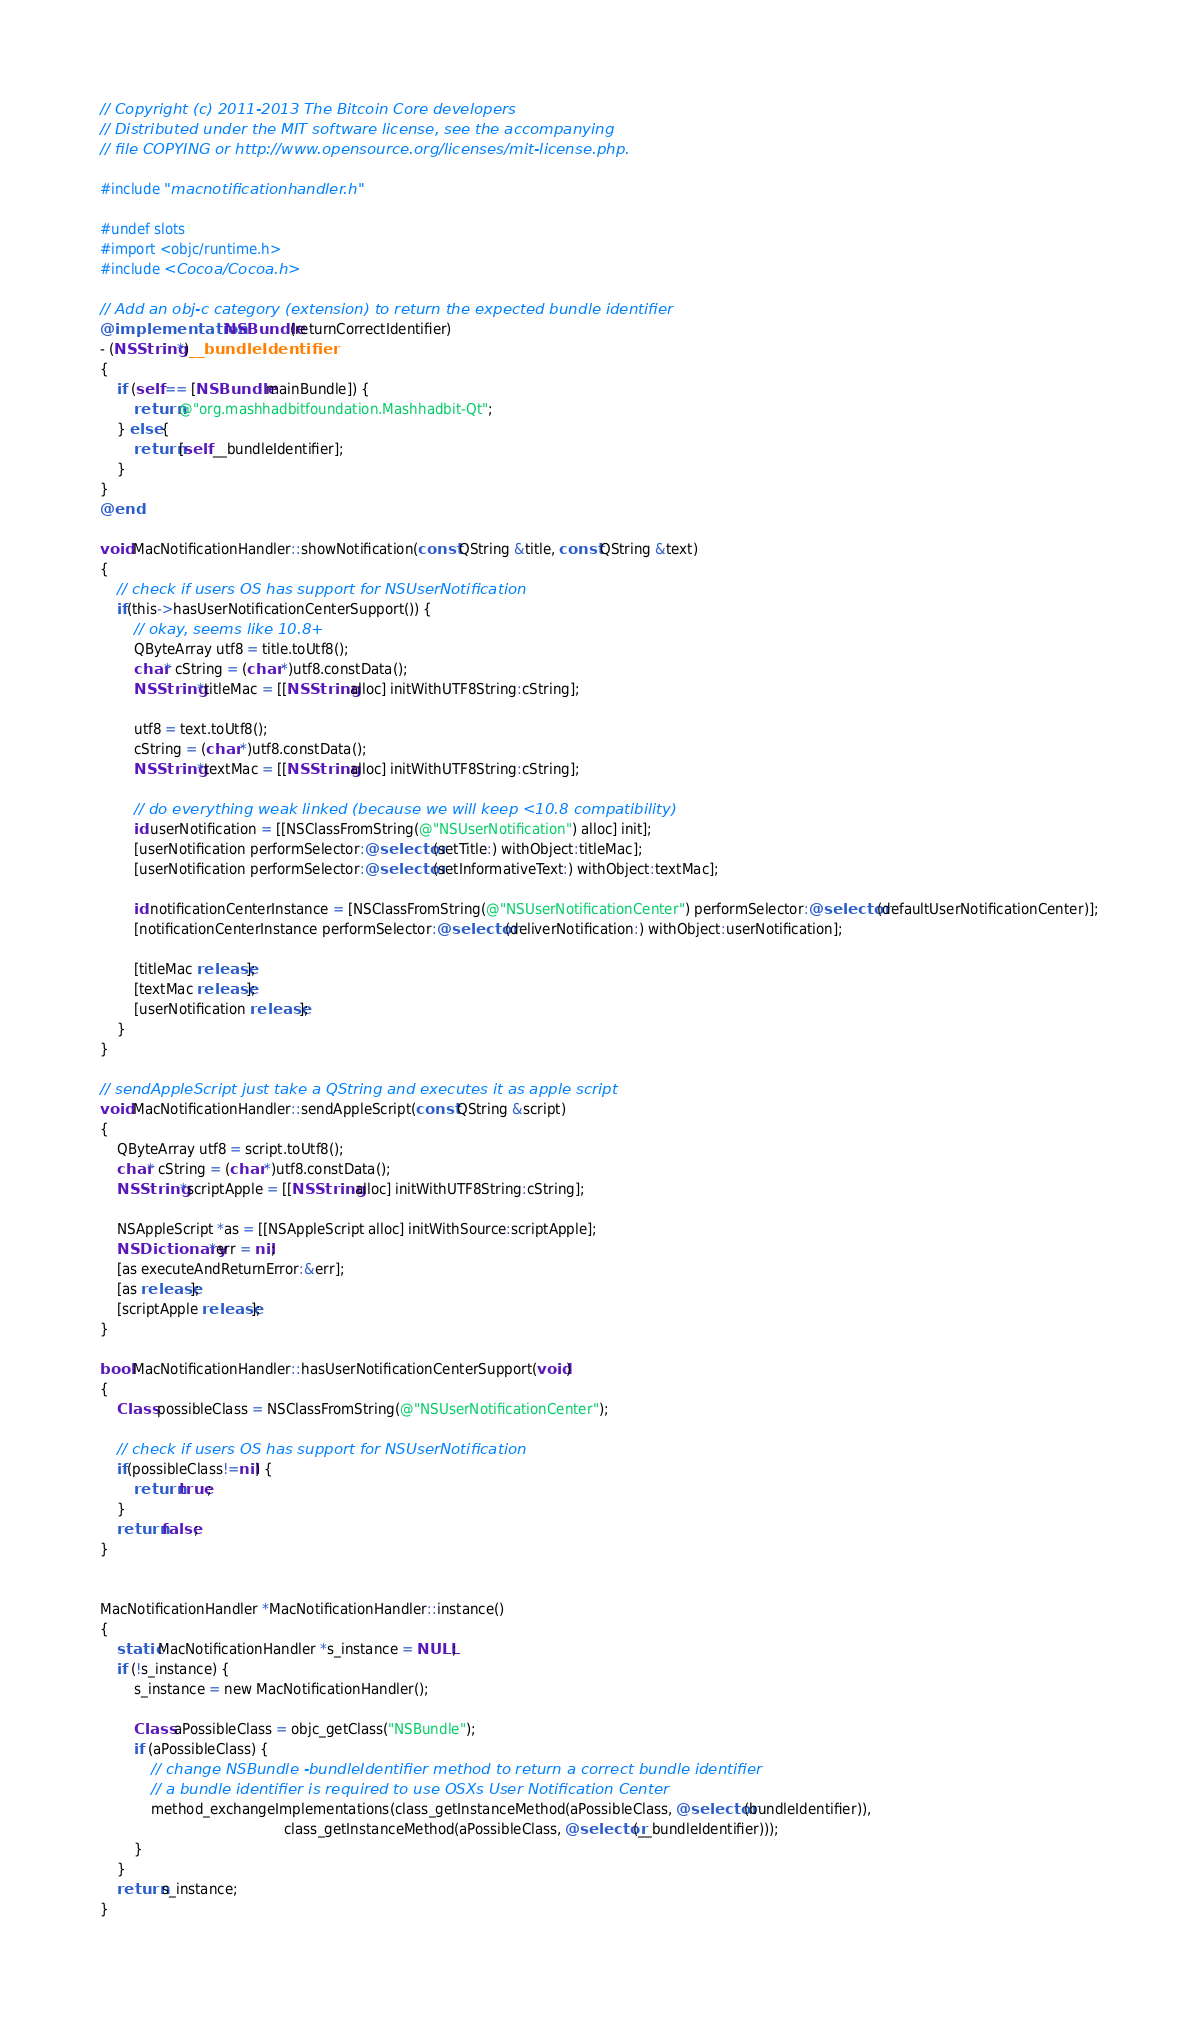Convert code to text. <code><loc_0><loc_0><loc_500><loc_500><_ObjectiveC_>// Copyright (c) 2011-2013 The Bitcoin Core developers
// Distributed under the MIT software license, see the accompanying
// file COPYING or http://www.opensource.org/licenses/mit-license.php.

#include "macnotificationhandler.h"

#undef slots
#import <objc/runtime.h>
#include <Cocoa/Cocoa.h>

// Add an obj-c category (extension) to return the expected bundle identifier
@implementation NSBundle(returnCorrectIdentifier)
- (NSString *)__bundleIdentifier
{
    if (self == [NSBundle mainBundle]) {
        return @"org.mashhadbitfoundation.Mashhadbit-Qt";
    } else {
        return [self __bundleIdentifier];
    }
}
@end

void MacNotificationHandler::showNotification(const QString &title, const QString &text)
{
    // check if users OS has support for NSUserNotification
    if(this->hasUserNotificationCenterSupport()) {
        // okay, seems like 10.8+
        QByteArray utf8 = title.toUtf8();
        char* cString = (char *)utf8.constData();
        NSString *titleMac = [[NSString alloc] initWithUTF8String:cString];

        utf8 = text.toUtf8();
        cString = (char *)utf8.constData();
        NSString *textMac = [[NSString alloc] initWithUTF8String:cString];

        // do everything weak linked (because we will keep <10.8 compatibility)
        id userNotification = [[NSClassFromString(@"NSUserNotification") alloc] init];
        [userNotification performSelector:@selector(setTitle:) withObject:titleMac];
        [userNotification performSelector:@selector(setInformativeText:) withObject:textMac];

        id notificationCenterInstance = [NSClassFromString(@"NSUserNotificationCenter") performSelector:@selector(defaultUserNotificationCenter)];
        [notificationCenterInstance performSelector:@selector(deliverNotification:) withObject:userNotification];

        [titleMac release];
        [textMac release];
        [userNotification release];
    }
}

// sendAppleScript just take a QString and executes it as apple script
void MacNotificationHandler::sendAppleScript(const QString &script)
{
    QByteArray utf8 = script.toUtf8();
    char* cString = (char *)utf8.constData();
    NSString *scriptApple = [[NSString alloc] initWithUTF8String:cString];

    NSAppleScript *as = [[NSAppleScript alloc] initWithSource:scriptApple];
    NSDictionary *err = nil;
    [as executeAndReturnError:&err];
    [as release];
    [scriptApple release];
}

bool MacNotificationHandler::hasUserNotificationCenterSupport(void)
{
    Class possibleClass = NSClassFromString(@"NSUserNotificationCenter");

    // check if users OS has support for NSUserNotification
    if(possibleClass!=nil) {
        return true;
    }
    return false;
}


MacNotificationHandler *MacNotificationHandler::instance()
{
    static MacNotificationHandler *s_instance = NULL;
    if (!s_instance) {
        s_instance = new MacNotificationHandler();
        
        Class aPossibleClass = objc_getClass("NSBundle");
        if (aPossibleClass) {
            // change NSBundle -bundleIdentifier method to return a correct bundle identifier
            // a bundle identifier is required to use OSXs User Notification Center
            method_exchangeImplementations(class_getInstanceMethod(aPossibleClass, @selector(bundleIdentifier)),
                                           class_getInstanceMethod(aPossibleClass, @selector(__bundleIdentifier)));
        }
    }
    return s_instance;
}
</code> 